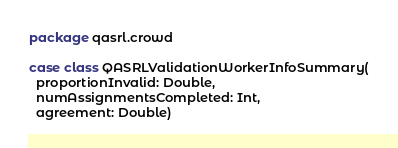<code> <loc_0><loc_0><loc_500><loc_500><_Scala_>package qasrl.crowd

case class QASRLValidationWorkerInfoSummary(
  proportionInvalid: Double,
  numAssignmentsCompleted: Int,
  agreement: Double)
</code> 